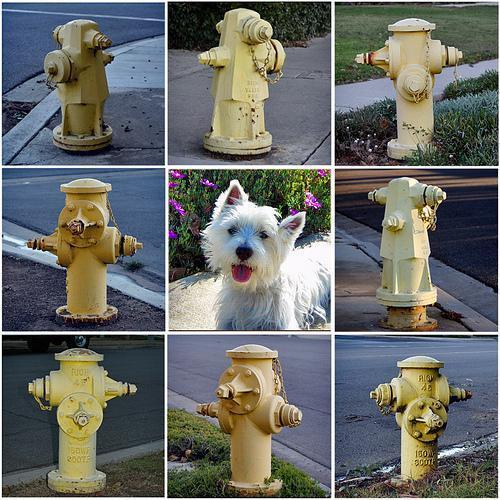How many fire hydrants are there?
Give a very brief answer. 8. 